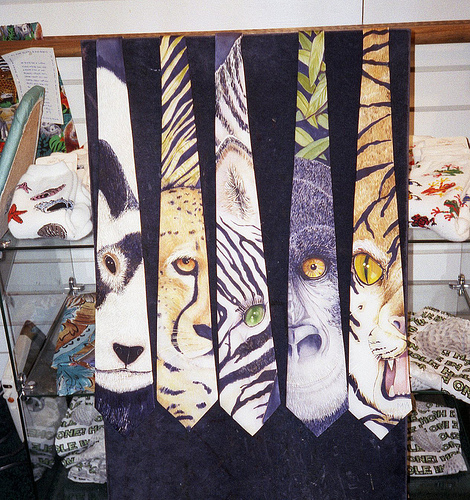Is the blanket on the left or on the right side of the picture? The decorative item with animal-themed ties is hanging on the left side of the picture, against a wall that displays other textiles. 